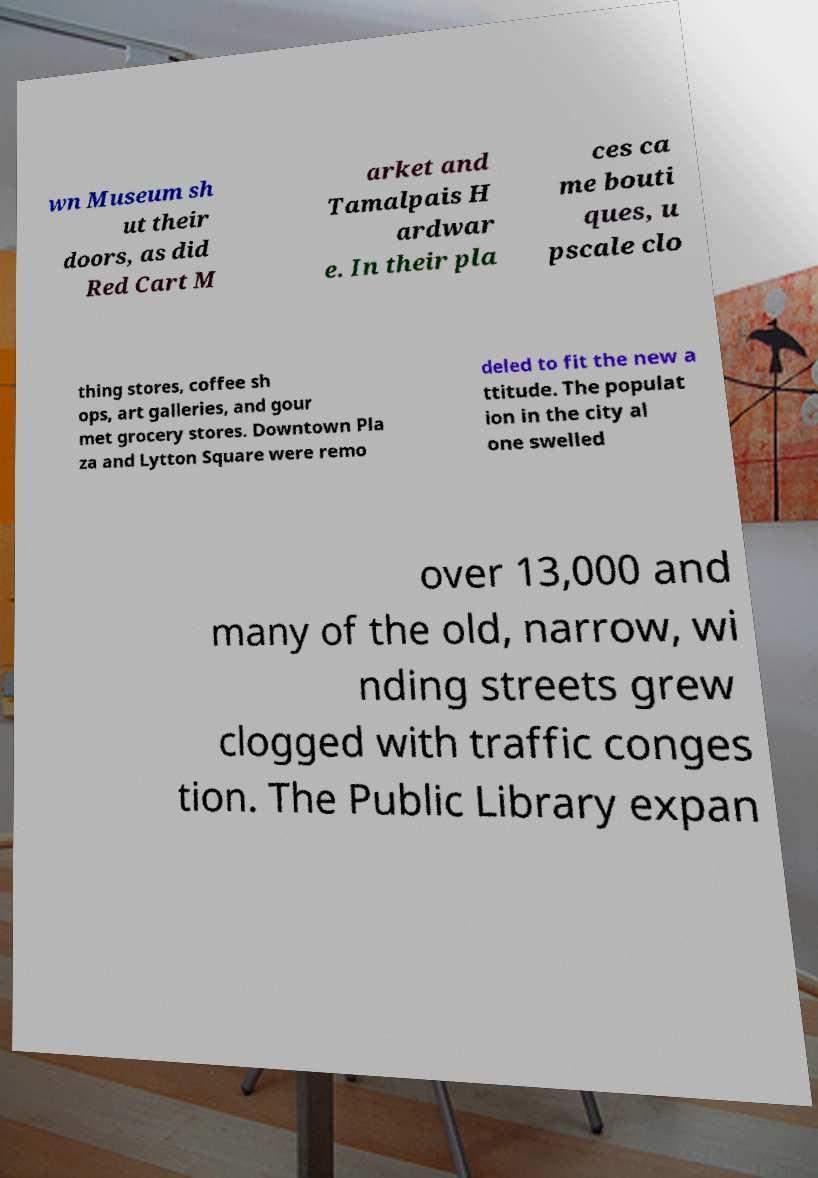What messages or text are displayed in this image? I need them in a readable, typed format. wn Museum sh ut their doors, as did Red Cart M arket and Tamalpais H ardwar e. In their pla ces ca me bouti ques, u pscale clo thing stores, coffee sh ops, art galleries, and gour met grocery stores. Downtown Pla za and Lytton Square were remo deled to fit the new a ttitude. The populat ion in the city al one swelled over 13,000 and many of the old, narrow, wi nding streets grew clogged with traffic conges tion. The Public Library expan 